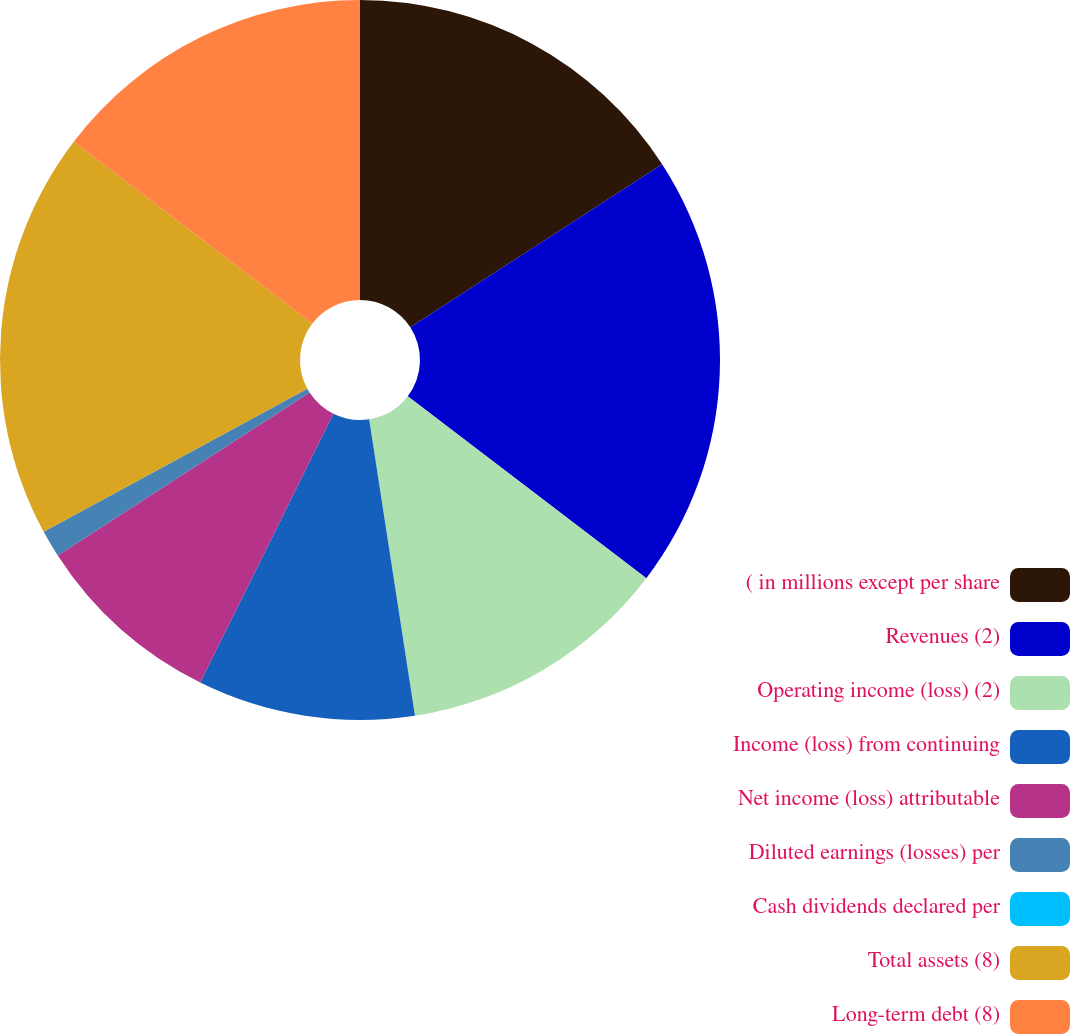<chart> <loc_0><loc_0><loc_500><loc_500><pie_chart><fcel>( in millions except per share<fcel>Revenues (2)<fcel>Operating income (loss) (2)<fcel>Income (loss) from continuing<fcel>Net income (loss) attributable<fcel>Diluted earnings (losses) per<fcel>Cash dividends declared per<fcel>Total assets (8)<fcel>Long-term debt (8)<nl><fcel>15.85%<fcel>19.51%<fcel>12.2%<fcel>9.76%<fcel>8.54%<fcel>1.22%<fcel>0.0%<fcel>18.29%<fcel>14.63%<nl></chart> 